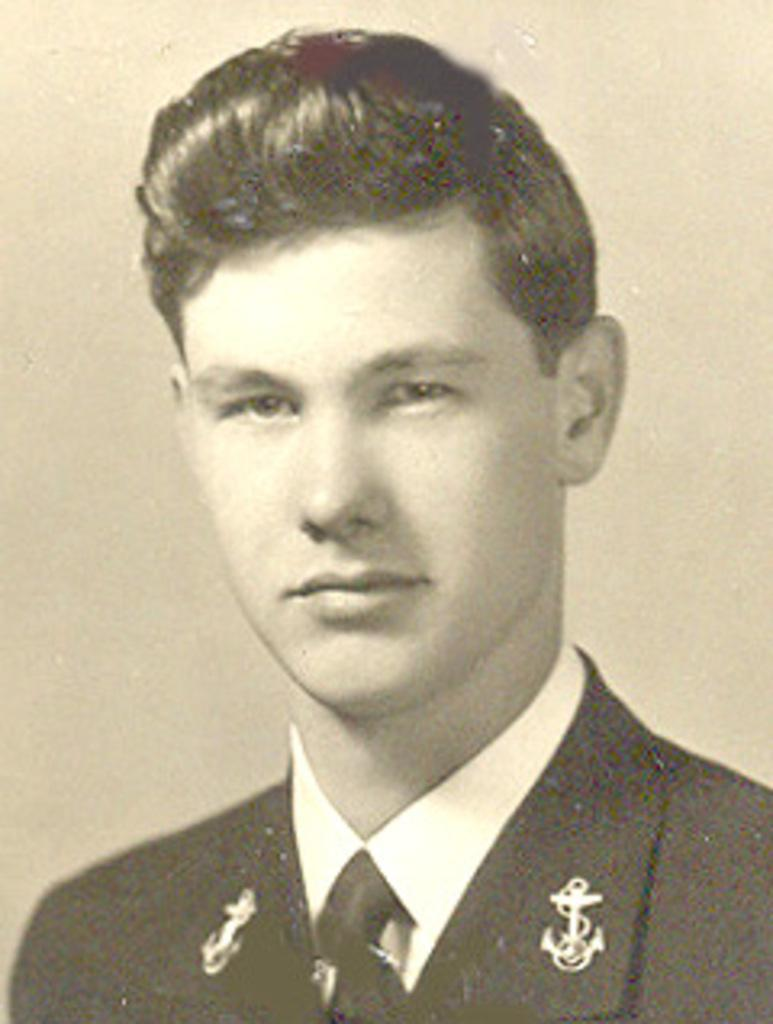What is the main subject of the image? There is a person's photo in the image. What can be seen in the background of the image? There is a wall in the image. What type of object is the image contained within? The image appears to be a photo frame. What type of oil is being used to create a thrilling effect in the image? There is no oil or thrilling effect present in the image; it is a photo of a person in a photo frame with a wall in the background. 